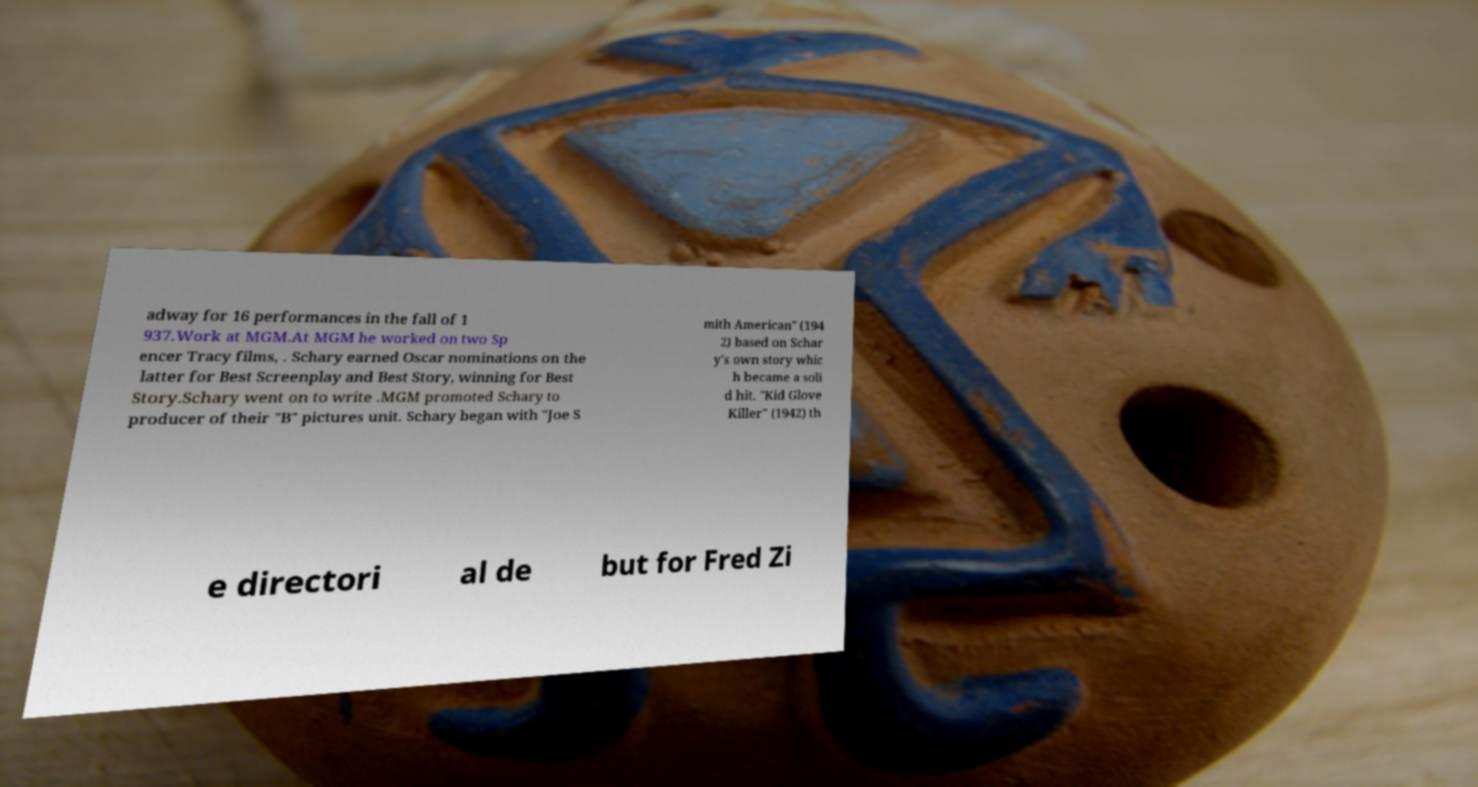I need the written content from this picture converted into text. Can you do that? adway for 16 performances in the fall of 1 937.Work at MGM.At MGM he worked on two Sp encer Tracy films, . Schary earned Oscar nominations on the latter for Best Screenplay and Best Story, winning for Best Story.Schary went on to write .MGM promoted Schary to producer of their "B" pictures unit. Schary began with "Joe S mith American" (194 2) based on Schar y's own story whic h became a soli d hit. "Kid Glove Killer" (1942) th e directori al de but for Fred Zi 